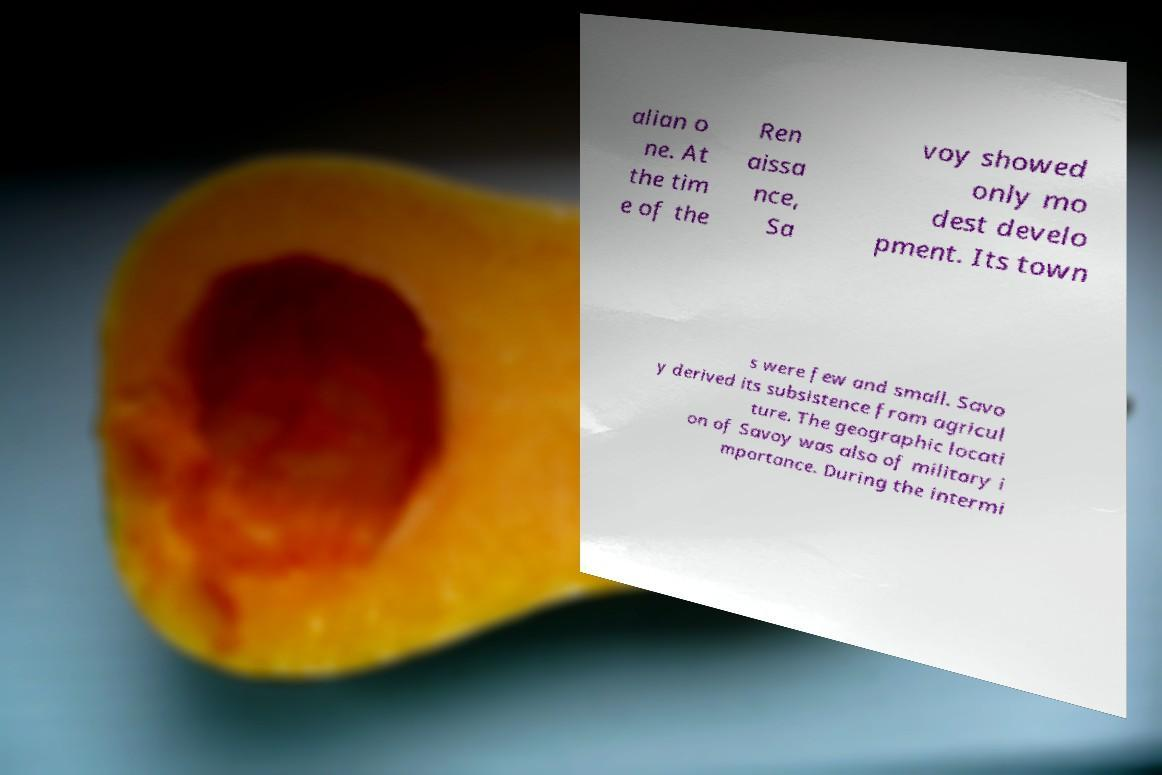For documentation purposes, I need the text within this image transcribed. Could you provide that? alian o ne. At the tim e of the Ren aissa nce, Sa voy showed only mo dest develo pment. Its town s were few and small. Savo y derived its subsistence from agricul ture. The geographic locati on of Savoy was also of military i mportance. During the intermi 